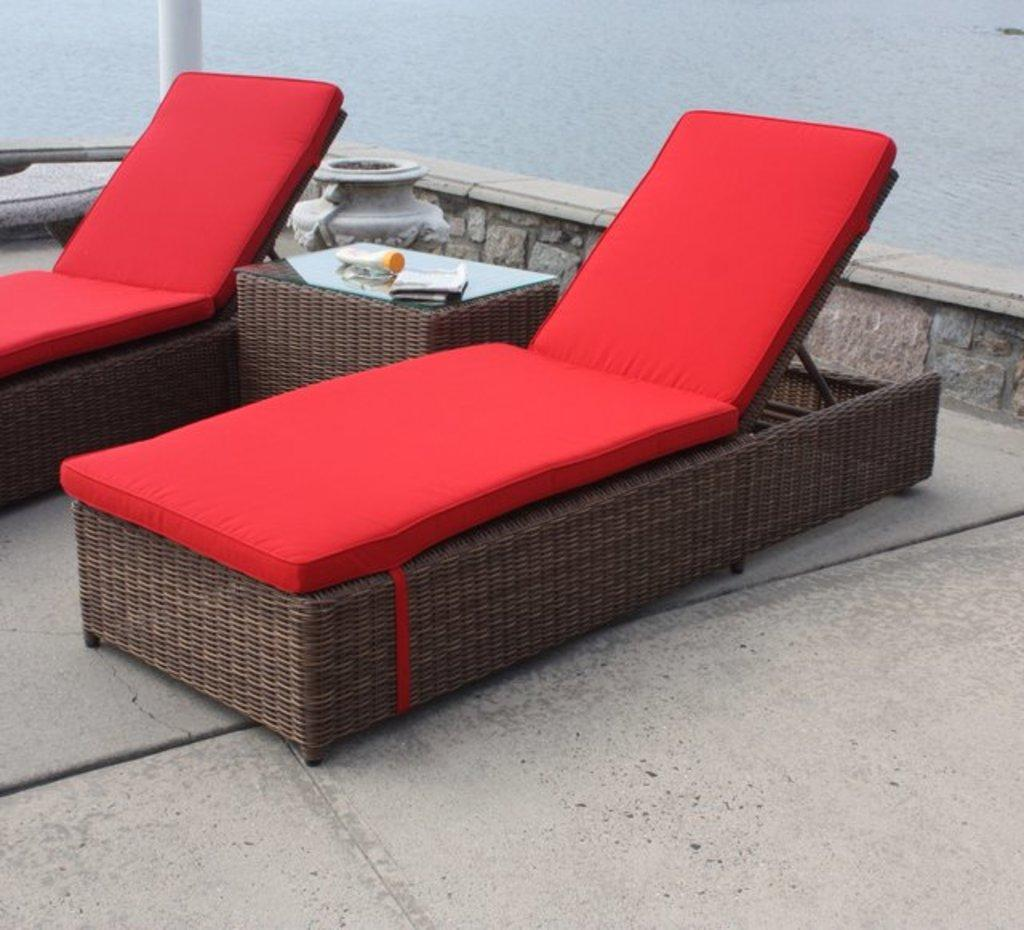What type of furniture is present in the image? There are sun loungers in the image. What is located on the table in the image? There are items on a table in the image. What can be seen in the background of the image? There is water visible in the background of the image. What room is the sun lounger located in? The provided facts do not mention a room, so it cannot be determined from the image. What interests are represented by the items on the table? The provided facts do not mention any specific interests, so it cannot be determined from the image. 